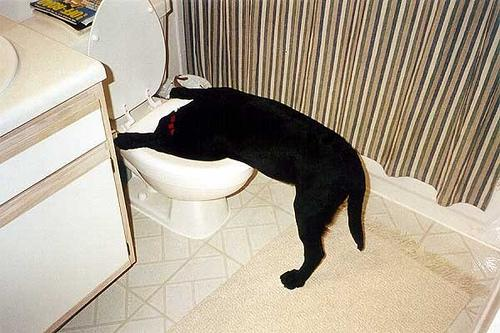Question: how did this happen?
Choices:
A. The cat just did it.
B. The dog did it.
C. The child did it.
D. The wind did it.
Answer with the letter. Answer: A Question: who is taking the picture?
Choices:
A. A realtor.
B. The cat's owner.
C. The mother.
D. The veterinarian.
Answer with the letter. Answer: B 